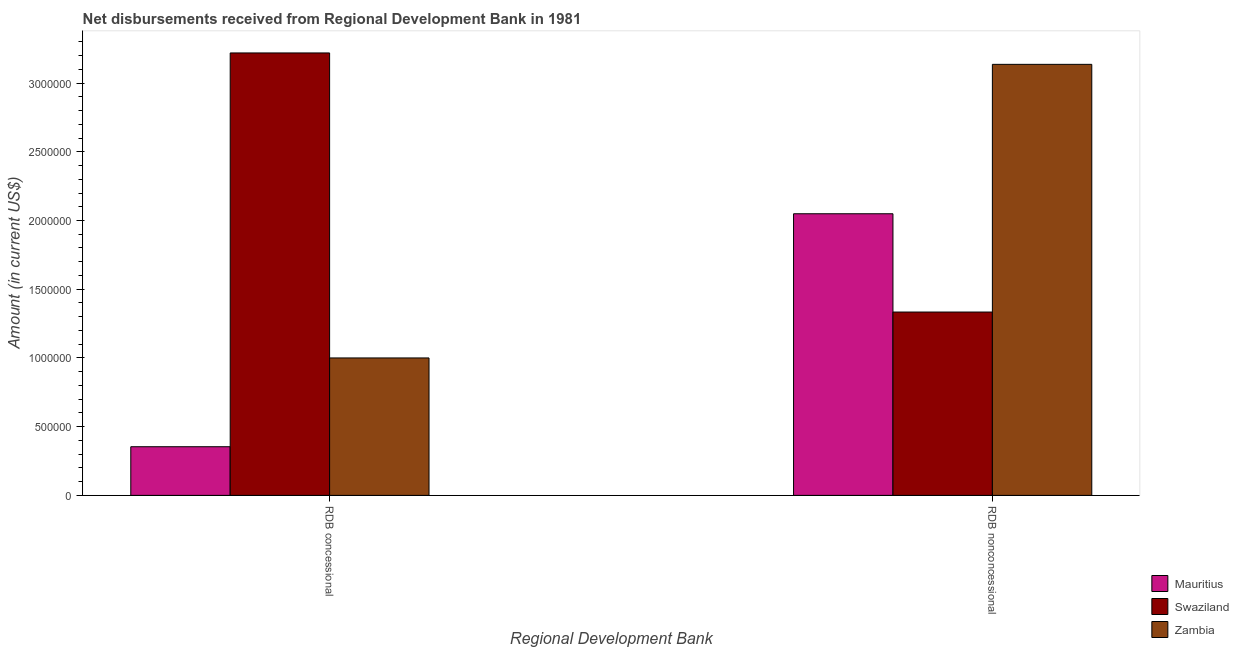How many different coloured bars are there?
Make the answer very short. 3. How many groups of bars are there?
Provide a succinct answer. 2. Are the number of bars per tick equal to the number of legend labels?
Give a very brief answer. Yes. Are the number of bars on each tick of the X-axis equal?
Offer a very short reply. Yes. What is the label of the 1st group of bars from the left?
Your response must be concise. RDB concessional. What is the net concessional disbursements from rdb in Mauritius?
Give a very brief answer. 3.54e+05. Across all countries, what is the maximum net concessional disbursements from rdb?
Keep it short and to the point. 3.22e+06. Across all countries, what is the minimum net concessional disbursements from rdb?
Make the answer very short. 3.54e+05. In which country was the net concessional disbursements from rdb maximum?
Your response must be concise. Swaziland. In which country was the net non concessional disbursements from rdb minimum?
Ensure brevity in your answer.  Swaziland. What is the total net concessional disbursements from rdb in the graph?
Keep it short and to the point. 4.57e+06. What is the difference between the net non concessional disbursements from rdb in Zambia and that in Mauritius?
Give a very brief answer. 1.09e+06. What is the difference between the net non concessional disbursements from rdb in Swaziland and the net concessional disbursements from rdb in Zambia?
Your response must be concise. 3.34e+05. What is the average net concessional disbursements from rdb per country?
Keep it short and to the point. 1.52e+06. What is the difference between the net non concessional disbursements from rdb and net concessional disbursements from rdb in Zambia?
Provide a succinct answer. 2.14e+06. In how many countries, is the net concessional disbursements from rdb greater than 400000 US$?
Give a very brief answer. 2. What is the ratio of the net concessional disbursements from rdb in Zambia to that in Swaziland?
Your response must be concise. 0.31. In how many countries, is the net concessional disbursements from rdb greater than the average net concessional disbursements from rdb taken over all countries?
Make the answer very short. 1. What does the 1st bar from the left in RDB concessional represents?
Your answer should be very brief. Mauritius. What does the 1st bar from the right in RDB concessional represents?
Make the answer very short. Zambia. How many bars are there?
Give a very brief answer. 6. How many countries are there in the graph?
Offer a very short reply. 3. How are the legend labels stacked?
Your response must be concise. Vertical. What is the title of the graph?
Ensure brevity in your answer.  Net disbursements received from Regional Development Bank in 1981. Does "Myanmar" appear as one of the legend labels in the graph?
Keep it short and to the point. No. What is the label or title of the X-axis?
Offer a very short reply. Regional Development Bank. What is the Amount (in current US$) in Mauritius in RDB concessional?
Your response must be concise. 3.54e+05. What is the Amount (in current US$) in Swaziland in RDB concessional?
Your answer should be very brief. 3.22e+06. What is the Amount (in current US$) of Mauritius in RDB nonconcessional?
Your answer should be compact. 2.05e+06. What is the Amount (in current US$) in Swaziland in RDB nonconcessional?
Your answer should be compact. 1.33e+06. What is the Amount (in current US$) of Zambia in RDB nonconcessional?
Provide a short and direct response. 3.14e+06. Across all Regional Development Bank, what is the maximum Amount (in current US$) of Mauritius?
Provide a succinct answer. 2.05e+06. Across all Regional Development Bank, what is the maximum Amount (in current US$) of Swaziland?
Provide a succinct answer. 3.22e+06. Across all Regional Development Bank, what is the maximum Amount (in current US$) in Zambia?
Ensure brevity in your answer.  3.14e+06. Across all Regional Development Bank, what is the minimum Amount (in current US$) in Mauritius?
Give a very brief answer. 3.54e+05. Across all Regional Development Bank, what is the minimum Amount (in current US$) in Swaziland?
Your response must be concise. 1.33e+06. What is the total Amount (in current US$) of Mauritius in the graph?
Your response must be concise. 2.40e+06. What is the total Amount (in current US$) in Swaziland in the graph?
Offer a very short reply. 4.55e+06. What is the total Amount (in current US$) of Zambia in the graph?
Provide a succinct answer. 4.14e+06. What is the difference between the Amount (in current US$) of Mauritius in RDB concessional and that in RDB nonconcessional?
Offer a very short reply. -1.70e+06. What is the difference between the Amount (in current US$) in Swaziland in RDB concessional and that in RDB nonconcessional?
Your response must be concise. 1.88e+06. What is the difference between the Amount (in current US$) in Zambia in RDB concessional and that in RDB nonconcessional?
Your response must be concise. -2.14e+06. What is the difference between the Amount (in current US$) of Mauritius in RDB concessional and the Amount (in current US$) of Swaziland in RDB nonconcessional?
Offer a very short reply. -9.80e+05. What is the difference between the Amount (in current US$) in Mauritius in RDB concessional and the Amount (in current US$) in Zambia in RDB nonconcessional?
Your answer should be very brief. -2.78e+06. What is the difference between the Amount (in current US$) in Swaziland in RDB concessional and the Amount (in current US$) in Zambia in RDB nonconcessional?
Provide a short and direct response. 8.30e+04. What is the average Amount (in current US$) of Mauritius per Regional Development Bank?
Your answer should be very brief. 1.20e+06. What is the average Amount (in current US$) of Swaziland per Regional Development Bank?
Make the answer very short. 2.28e+06. What is the average Amount (in current US$) in Zambia per Regional Development Bank?
Offer a very short reply. 2.07e+06. What is the difference between the Amount (in current US$) in Mauritius and Amount (in current US$) in Swaziland in RDB concessional?
Provide a short and direct response. -2.86e+06. What is the difference between the Amount (in current US$) in Mauritius and Amount (in current US$) in Zambia in RDB concessional?
Offer a very short reply. -6.46e+05. What is the difference between the Amount (in current US$) in Swaziland and Amount (in current US$) in Zambia in RDB concessional?
Give a very brief answer. 2.22e+06. What is the difference between the Amount (in current US$) of Mauritius and Amount (in current US$) of Swaziland in RDB nonconcessional?
Your answer should be very brief. 7.15e+05. What is the difference between the Amount (in current US$) of Mauritius and Amount (in current US$) of Zambia in RDB nonconcessional?
Offer a terse response. -1.09e+06. What is the difference between the Amount (in current US$) of Swaziland and Amount (in current US$) of Zambia in RDB nonconcessional?
Your response must be concise. -1.80e+06. What is the ratio of the Amount (in current US$) of Mauritius in RDB concessional to that in RDB nonconcessional?
Your answer should be compact. 0.17. What is the ratio of the Amount (in current US$) of Swaziland in RDB concessional to that in RDB nonconcessional?
Offer a very short reply. 2.41. What is the ratio of the Amount (in current US$) in Zambia in RDB concessional to that in RDB nonconcessional?
Give a very brief answer. 0.32. What is the difference between the highest and the second highest Amount (in current US$) of Mauritius?
Your response must be concise. 1.70e+06. What is the difference between the highest and the second highest Amount (in current US$) in Swaziland?
Your answer should be very brief. 1.88e+06. What is the difference between the highest and the second highest Amount (in current US$) of Zambia?
Give a very brief answer. 2.14e+06. What is the difference between the highest and the lowest Amount (in current US$) in Mauritius?
Make the answer very short. 1.70e+06. What is the difference between the highest and the lowest Amount (in current US$) in Swaziland?
Ensure brevity in your answer.  1.88e+06. What is the difference between the highest and the lowest Amount (in current US$) in Zambia?
Ensure brevity in your answer.  2.14e+06. 